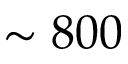Convert formula to latex. <formula><loc_0><loc_0><loc_500><loc_500>\sim 8 0 0</formula> 